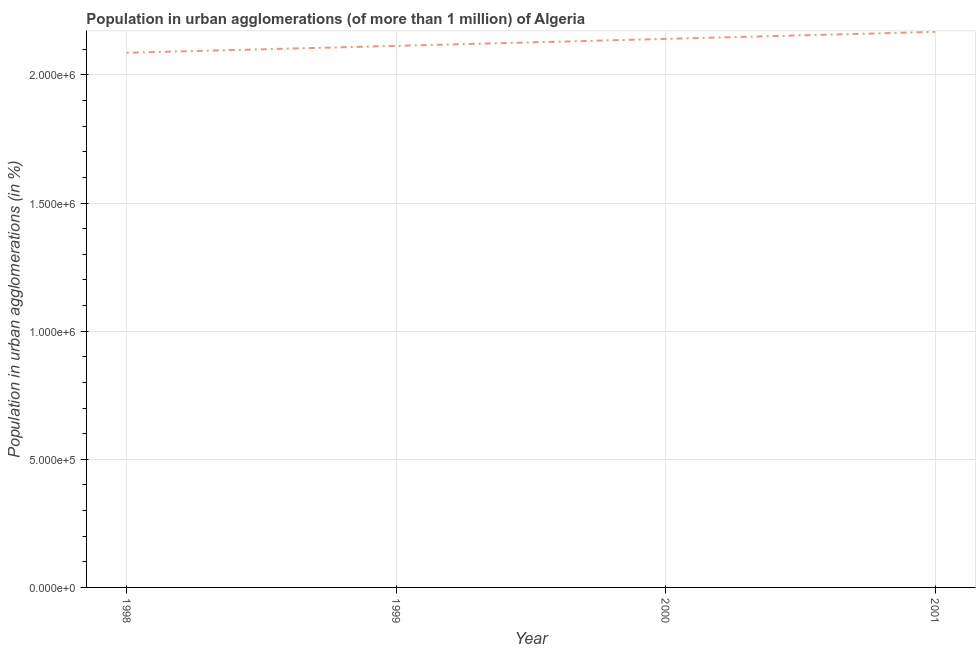What is the population in urban agglomerations in 1999?
Your response must be concise. 2.11e+06. Across all years, what is the maximum population in urban agglomerations?
Ensure brevity in your answer.  2.17e+06. Across all years, what is the minimum population in urban agglomerations?
Give a very brief answer. 2.09e+06. In which year was the population in urban agglomerations maximum?
Offer a terse response. 2001. In which year was the population in urban agglomerations minimum?
Make the answer very short. 1998. What is the sum of the population in urban agglomerations?
Keep it short and to the point. 8.51e+06. What is the difference between the population in urban agglomerations in 1998 and 2000?
Your answer should be very brief. -5.40e+04. What is the average population in urban agglomerations per year?
Provide a short and direct response. 2.13e+06. What is the median population in urban agglomerations?
Offer a very short reply. 2.13e+06. In how many years, is the population in urban agglomerations greater than 1200000 %?
Give a very brief answer. 4. What is the ratio of the population in urban agglomerations in 1999 to that in 2001?
Your answer should be very brief. 0.97. Is the population in urban agglomerations in 1999 less than that in 2000?
Provide a short and direct response. Yes. What is the difference between the highest and the second highest population in urban agglomerations?
Offer a very short reply. 2.75e+04. What is the difference between the highest and the lowest population in urban agglomerations?
Your answer should be very brief. 8.15e+04. In how many years, is the population in urban agglomerations greater than the average population in urban agglomerations taken over all years?
Ensure brevity in your answer.  2. How many years are there in the graph?
Offer a terse response. 4. What is the difference between two consecutive major ticks on the Y-axis?
Keep it short and to the point. 5.00e+05. Are the values on the major ticks of Y-axis written in scientific E-notation?
Keep it short and to the point. Yes. Does the graph contain grids?
Provide a succinct answer. Yes. What is the title of the graph?
Offer a terse response. Population in urban agglomerations (of more than 1 million) of Algeria. What is the label or title of the X-axis?
Your answer should be compact. Year. What is the label or title of the Y-axis?
Your answer should be very brief. Population in urban agglomerations (in %). What is the Population in urban agglomerations (in %) of 1998?
Offer a terse response. 2.09e+06. What is the Population in urban agglomerations (in %) in 1999?
Your response must be concise. 2.11e+06. What is the Population in urban agglomerations (in %) of 2000?
Your answer should be compact. 2.14e+06. What is the Population in urban agglomerations (in %) in 2001?
Your answer should be very brief. 2.17e+06. What is the difference between the Population in urban agglomerations (in %) in 1998 and 1999?
Your answer should be compact. -2.68e+04. What is the difference between the Population in urban agglomerations (in %) in 1998 and 2000?
Keep it short and to the point. -5.40e+04. What is the difference between the Population in urban agglomerations (in %) in 1998 and 2001?
Make the answer very short. -8.15e+04. What is the difference between the Population in urban agglomerations (in %) in 1999 and 2000?
Keep it short and to the point. -2.72e+04. What is the difference between the Population in urban agglomerations (in %) in 1999 and 2001?
Ensure brevity in your answer.  -5.47e+04. What is the difference between the Population in urban agglomerations (in %) in 2000 and 2001?
Provide a short and direct response. -2.75e+04. What is the ratio of the Population in urban agglomerations (in %) in 1998 to that in 2001?
Your answer should be very brief. 0.96. What is the ratio of the Population in urban agglomerations (in %) in 1999 to that in 2000?
Provide a short and direct response. 0.99. What is the ratio of the Population in urban agglomerations (in %) in 1999 to that in 2001?
Ensure brevity in your answer.  0.97. 